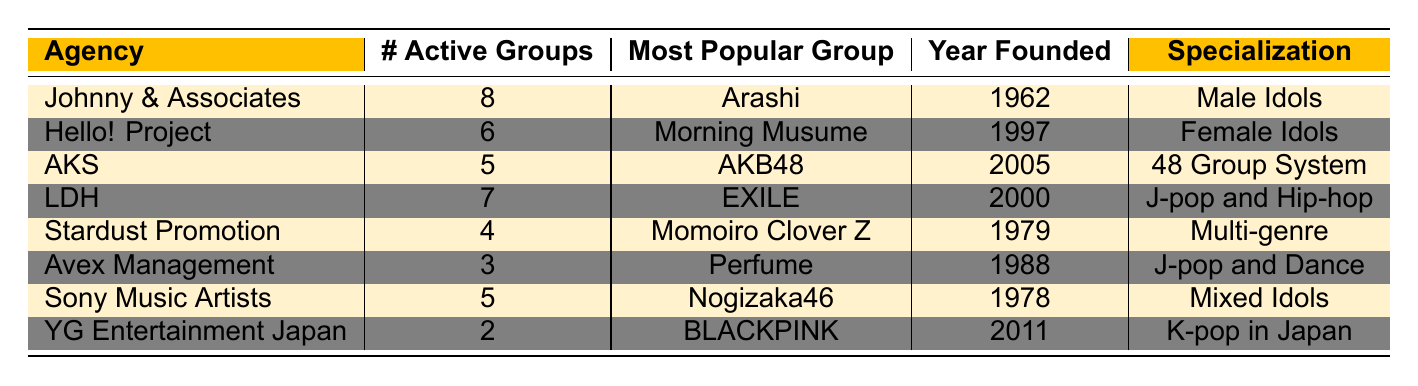What is the most popular group from Hello! Project? The table shows that the most popular group from Hello! Project is Morning Musume.
Answer: Morning Musume Which agency has the highest number of active groups? By examining the table, Johnny & Associates has the highest number of active groups with a count of 8.
Answer: Johnny & Associates How many active groups does Avex Management have? The table indicates that Avex Management has 3 active groups.
Answer: 3 What is the specialization of AKS? The table lists that the specialization of AKS is the 48 Group System.
Answer: 48 Group System What is the difference in the number of active groups between LDH and Stardust Promotion? LDH has 7 active groups and Stardust Promotion has 4 active groups. The difference is 7 - 4 = 3.
Answer: 3 Which agency was founded the earliest? Looking at the Year Founded column, Johnny & Associates was founded in 1962, making it the earliest founded agency.
Answer: Johnny & Associates What is the average number of active groups across all agencies? To find the average, sum all active groups: 8 + 6 + 5 + 7 + 4 + 3 + 5 + 2 = 40. The number of agencies is 8, so average = 40/8 = 5.
Answer: 5 Is there any agency that specializes in K-pop in Japan? Yes, the table shows that YG Entertainment Japan specializes in K-pop in Japan.
Answer: Yes How many agencies have more than 5 active groups? By reviewing the table, only Johnny & Associates (8) and LDH (7) have more than 5 active groups, making a total of 2 agencies.
Answer: 2 Which agency has the lowest number of active groups, and what is that number? The table shows that YG Entertainment Japan has the lowest number of active groups, which is 2.
Answer: YG Entertainment Japan, 2 